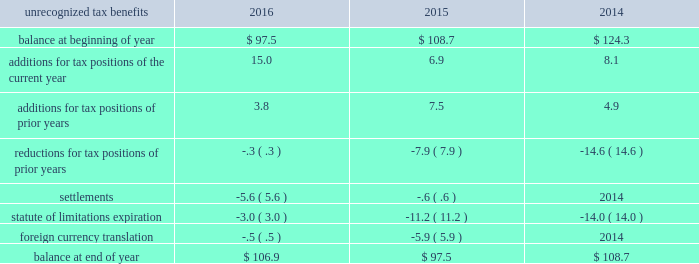The valuation allowance as of 30 september 2016 of $ 155.2 primarily related to the tax benefit on the federal capital loss carryforward of $ 48.0 , tax benefit of foreign loss carryforwards of $ 37.7 , and capital assets of $ 58.0 that were generated from the loss recorded on the exit from the energy-from-waste business in 2016 .
If events warrant the reversal of the valuation allowance , it would result in a reduction of tax expense .
We believe it is more likely than not that future earnings and reversal of deferred tax liabilities will be sufficient to utilize our deferred tax assets , net of existing valuation allowance , at 30 september 2016 .
The deferred tax liability associated with unremitted earnings of foreign entities decreased in part due to the dividend to repatriate cash from a foreign subsidiary in south korea .
This amount was also impacted by ongoing activity including earnings , dividend payments , tax credit adjustments , and currency translation impacting the undistributed earnings of our foreign subsidiaries and corporate joint ventures which are not considered to be indefinitely reinvested outside of the u.s .
We record u.s .
Income taxes on the undistributed earnings of our foreign subsidiaries and corporate joint ventures unless those earnings are indefinitely reinvested outside of the u.s .
These cumulative undistributed earnings that are considered to be indefinitely reinvested in foreign subsidiaries and corporate joint ventures are included in retained earnings on the consolidated balance sheets and amounted to $ 6300.9 as of 30 september 2016 .
An estimated $ 1467.8 in u.s .
Income and foreign withholding taxes would be due if these earnings were remitted as dividends after payment of all deferred taxes .
A reconciliation of the beginning and ending amount of the unrecognized tax benefits is as follows: .
At 30 september 2016 and 2015 , we had $ 106.9 and $ 97.5 of unrecognized tax benefits , excluding interest and penalties , of which $ 64.5 and $ 62.5 , respectively , would impact the effective tax rate if recognized .
Interest and penalties related to unrecognized tax benefits are recorded as a component of income tax expense and totaled $ 2.3 in 2016 , $ ( 1.8 ) in 2015 , and $ 1.2 in 2014 .
Our accrued balance for interest and penalties was $ 9.8 and $ 7.5 as of 30 september 2016 and 2015 , respectively. .
Considering the years 2014-2016 , what is the average value for additions for tax positions of the current year? 
Rationale: it is the sum of all additions for tax positions of the current year divided by three ( number of years ) .
Computations: table_average(additions for tax positions of the current year, none)
Answer: 10.0. 